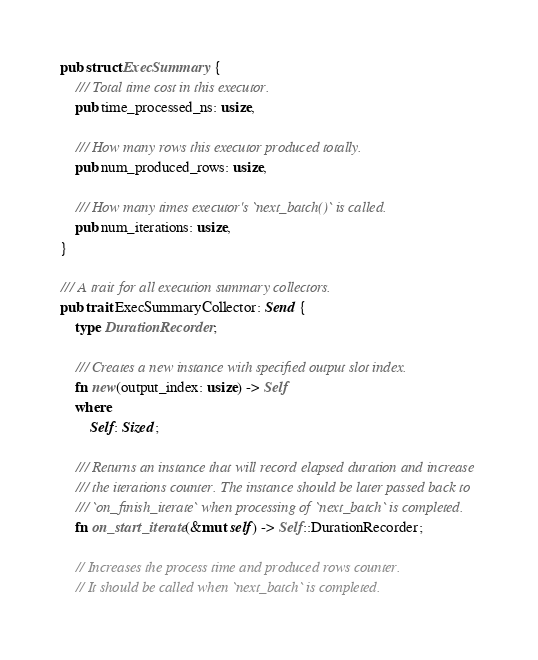<code> <loc_0><loc_0><loc_500><loc_500><_Rust_>pub struct ExecSummary {
    /// Total time cost in this executor.
    pub time_processed_ns: usize,

    /// How many rows this executor produced totally.
    pub num_produced_rows: usize,

    /// How many times executor's `next_batch()` is called.
    pub num_iterations: usize,
}

/// A trait for all execution summary collectors.
pub trait ExecSummaryCollector: Send {
    type DurationRecorder;

    /// Creates a new instance with specified output slot index.
    fn new(output_index: usize) -> Self
    where
        Self: Sized;

    /// Returns an instance that will record elapsed duration and increase
    /// the iterations counter. The instance should be later passed back to
    /// `on_finish_iterate` when processing of `next_batch` is completed.
    fn on_start_iterate(&mut self) -> Self::DurationRecorder;

    // Increases the process time and produced rows counter.
    // It should be called when `next_batch` is completed.</code> 